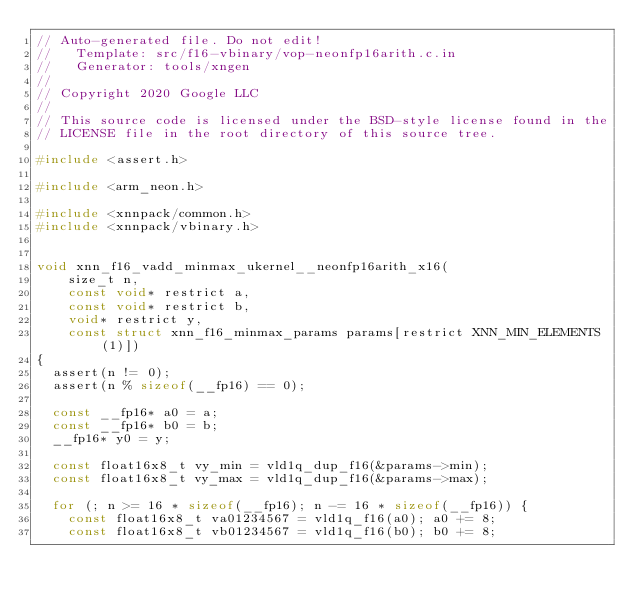<code> <loc_0><loc_0><loc_500><loc_500><_C_>// Auto-generated file. Do not edit!
//   Template: src/f16-vbinary/vop-neonfp16arith.c.in
//   Generator: tools/xngen
//
// Copyright 2020 Google LLC
//
// This source code is licensed under the BSD-style license found in the
// LICENSE file in the root directory of this source tree.

#include <assert.h>

#include <arm_neon.h>

#include <xnnpack/common.h>
#include <xnnpack/vbinary.h>


void xnn_f16_vadd_minmax_ukernel__neonfp16arith_x16(
    size_t n,
    const void* restrict a,
    const void* restrict b,
    void* restrict y,
    const struct xnn_f16_minmax_params params[restrict XNN_MIN_ELEMENTS(1)])
{
  assert(n != 0);
  assert(n % sizeof(__fp16) == 0);

  const __fp16* a0 = a;
  const __fp16* b0 = b;
  __fp16* y0 = y;

  const float16x8_t vy_min = vld1q_dup_f16(&params->min);
  const float16x8_t vy_max = vld1q_dup_f16(&params->max);

  for (; n >= 16 * sizeof(__fp16); n -= 16 * sizeof(__fp16)) {
    const float16x8_t va01234567 = vld1q_f16(a0); a0 += 8;
    const float16x8_t vb01234567 = vld1q_f16(b0); b0 += 8;</code> 